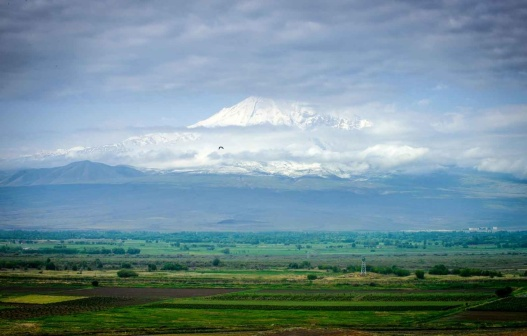What stories might the clouds in this image be telling us? The clouds, with their scattered yet purposeful formation, seem to be whispering tales of the mountain’s ancient existence. They hint at the ever-changing weather that shapes the land, the timeless dance between sky and earth. Perhaps they tell stories of past storms and calm days, of nature’s relentless yet harmonious flow. The partially obscured peak suggests a history of mystery and grandeur, a sentinel standing tall against the whims of time. 